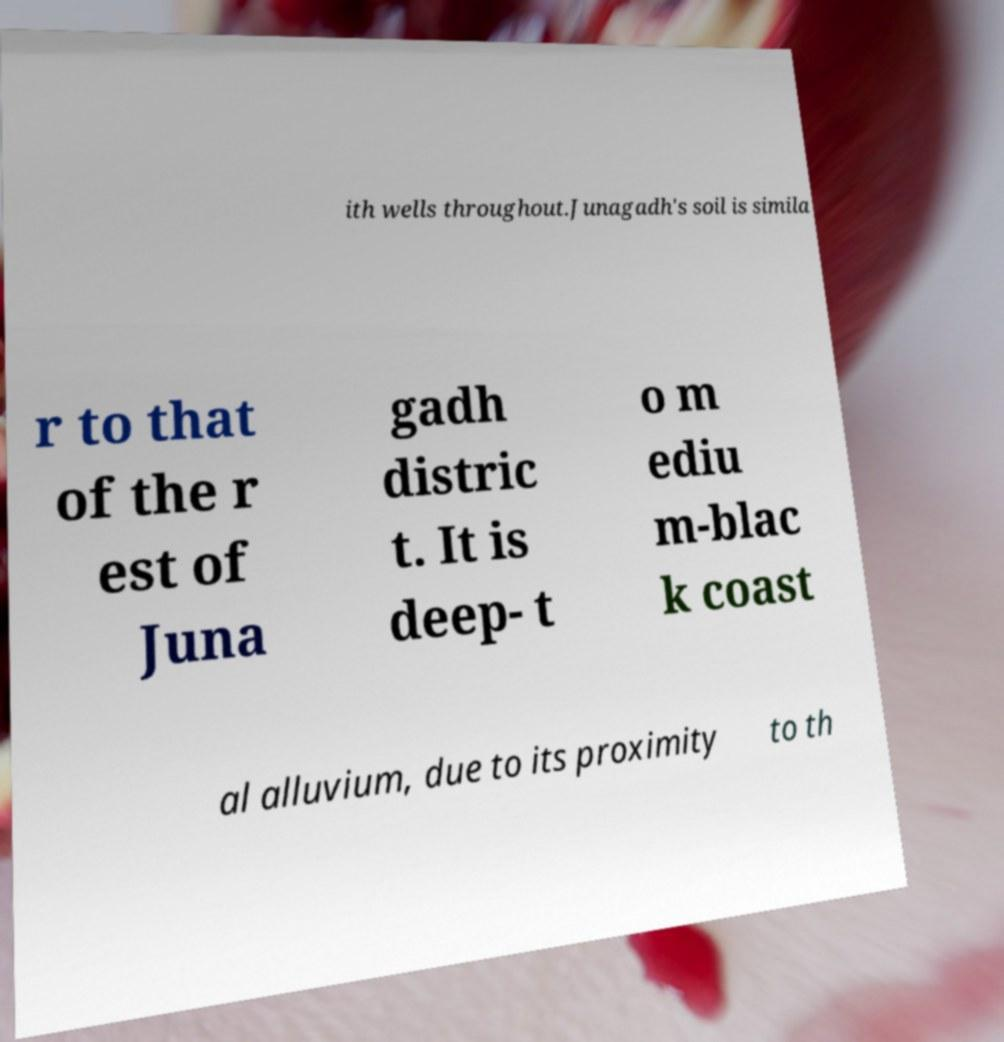Could you extract and type out the text from this image? ith wells throughout.Junagadh's soil is simila r to that of the r est of Juna gadh distric t. It is deep- t o m ediu m-blac k coast al alluvium, due to its proximity to th 